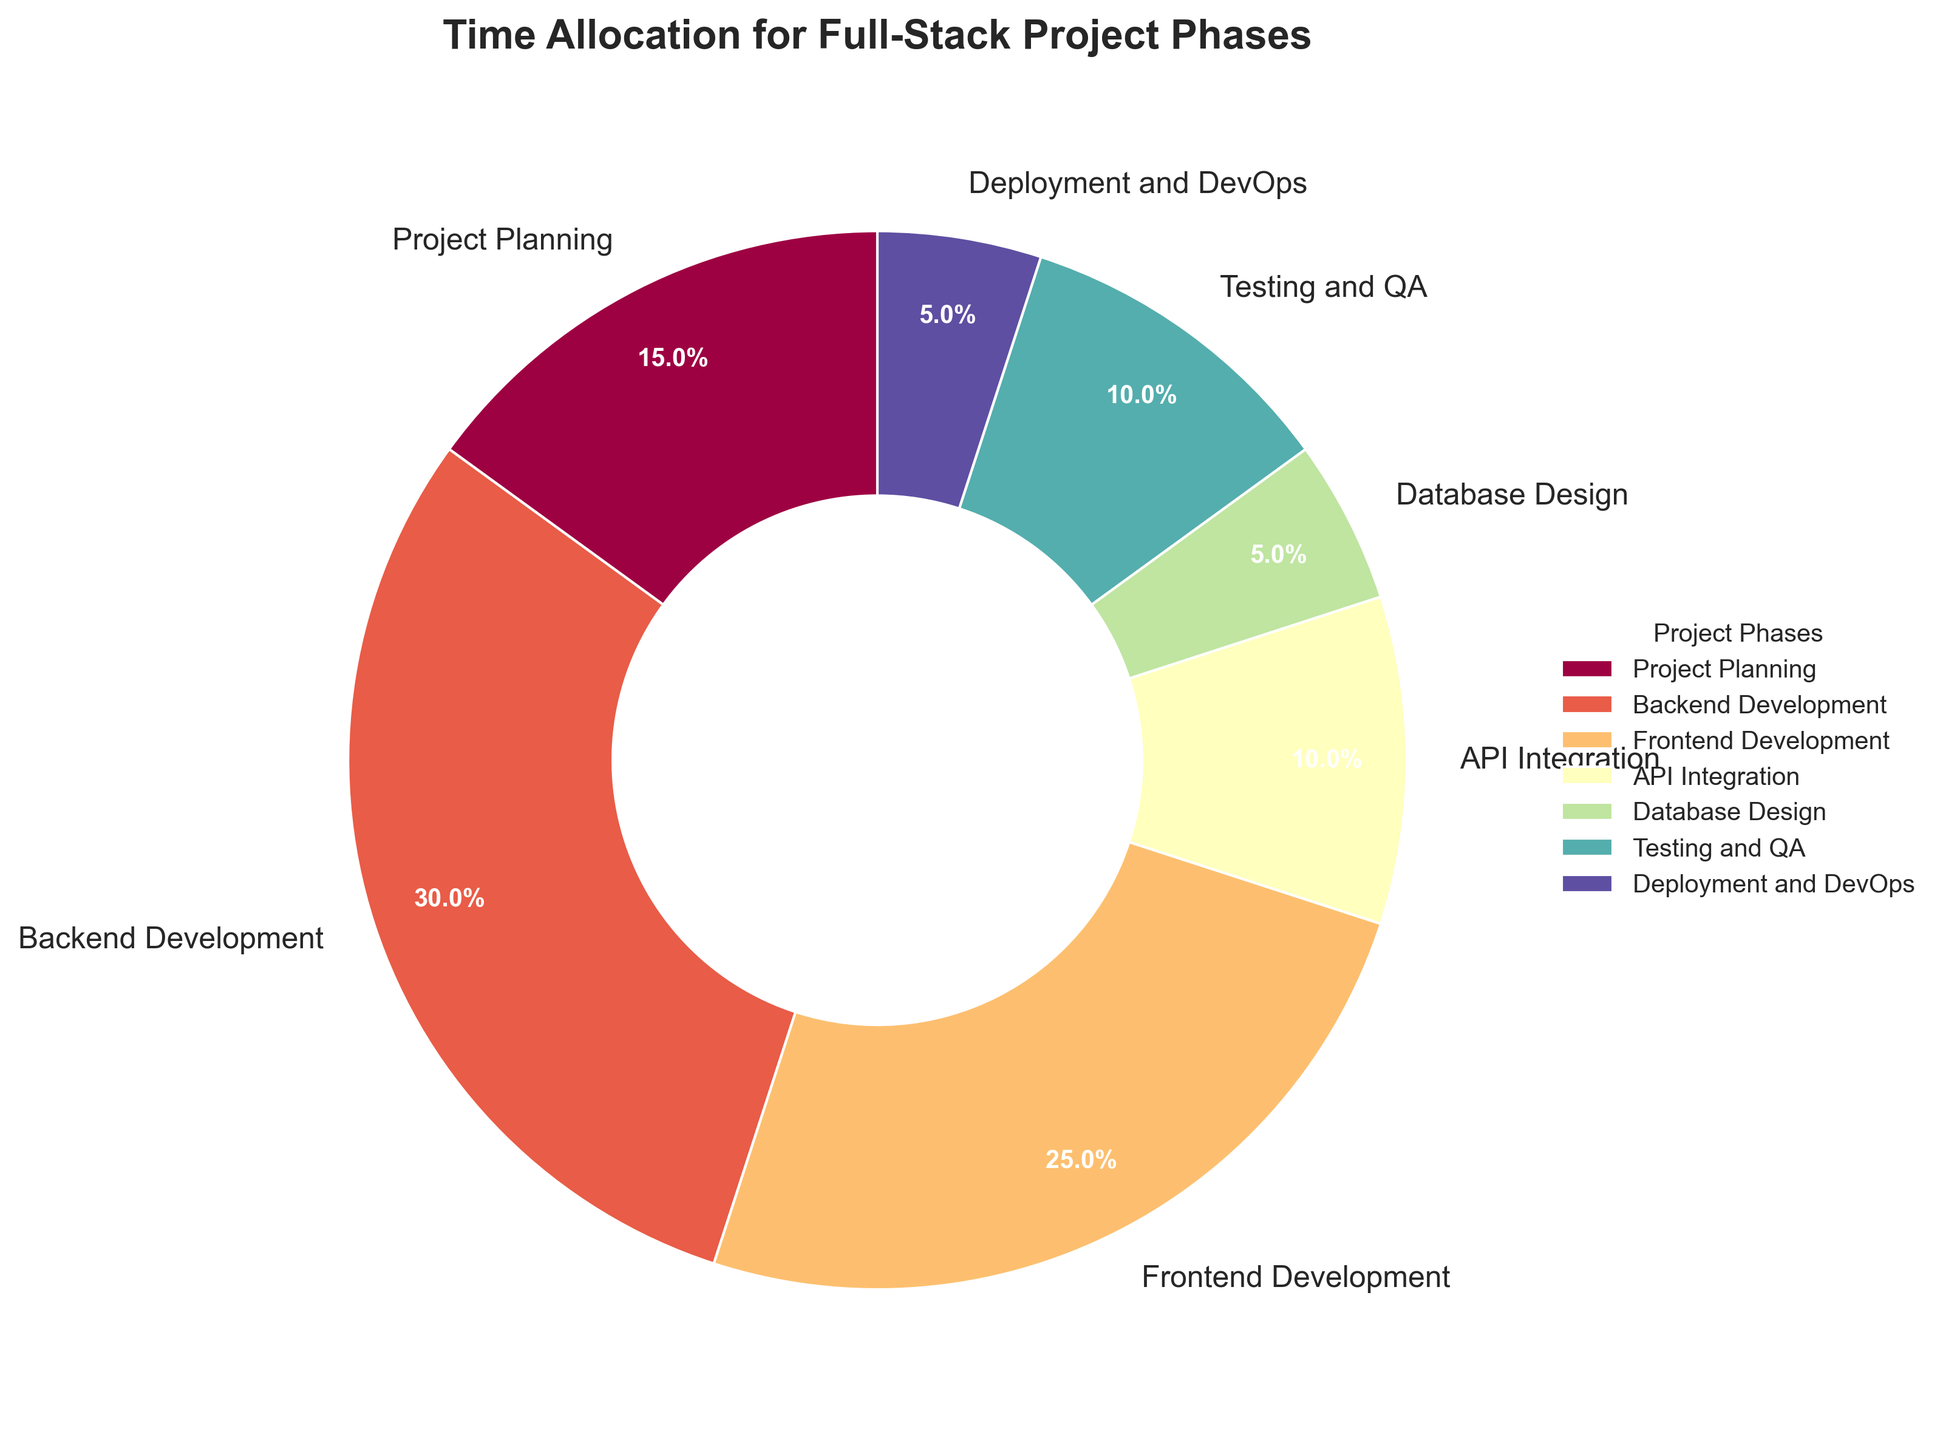Which phase takes up the largest portion of time allocation? The slice labeled 'Backend Development' appears to be the largest portion of the pie chart. This slice has the most substantial visual area, indicating it takes up the largest portion of the time allocation.
Answer: Backend Development What is the total time allocation for Frontend Development and Backend Development? The time allocation for Frontend Development is 25%, and for Backend Development, it is 30%. Adding these two values gives the total time allocation: 25% + 30% = 55%.
Answer: 55% Which phase occupies the smallest portion of the chart? The slice labeled 'Database Design' appears to be the smallest portion of the pie chart. This slice has the smallest visual area, which indicates it covers the smallest portion of the time allocation.
Answer: Database Design How much more time is allocated to Project Planning compared to Database Design? The time allocation for Project Planning is 15%, and for Database Design, it is 5%. The difference between these two values is 15% - 5% = 10%.
Answer: 10% Is the time allocated for API Integration greater than that for Deployment and DevOps? The time allocation for API Integration is 10%, and for Deployment and DevOps, it is 5%. Since 10% is greater than 5%, the time allocated for API Integration is indeed greater.
Answer: Yes What is the combined time allocation for Project Planning, Testing and QA, and Deployment and DevOps? The time allocation for Project Planning is 15%, for Testing and QA it is 10%, and for Deployment and DevOps, it is 5%. Adding these values gives the combined time allocation: 15% + 10% + 5% = 30%.
Answer: 30% Which phase is represented by the yellow slice in the pie chart? Observing the color distribution in the pie chart, the yellow slice corresponds to the label 'Frontend Development'.
Answer: Frontend Development How does the time allocation for Testing and QA compare to that for Frontend Development? The time allocation for Testing and QA is 10%, while for Frontend Development it is 25%. Comparing these, it shows that Frontend Development has a higher allocation than Testing and QA.
Answer: Frontend Development has higher allocation What percentage of time is allocated to phases other than Backend Development? The time allocation for Backend Development is 30%. Subtracting this from 100% gives the percentage for other phases: 100% - 30% = 70%.
Answer: 70% What is the average time allocation for API Integration, Testing and QA, and Deployment and DevOps? The time allocation for API Integration is 10%, for Testing and QA it is 10%, and for Deployment and DevOps, it is 5%. The average is (10% + 10% + 5%) / 3 = 25% / 3 ≈ 8.33%.
Answer: 8.33% 